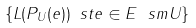<formula> <loc_0><loc_0><loc_500><loc_500>\{ L ( P _ { U } ( e ) ) \ s t e \in E \ s m U \}</formula> 